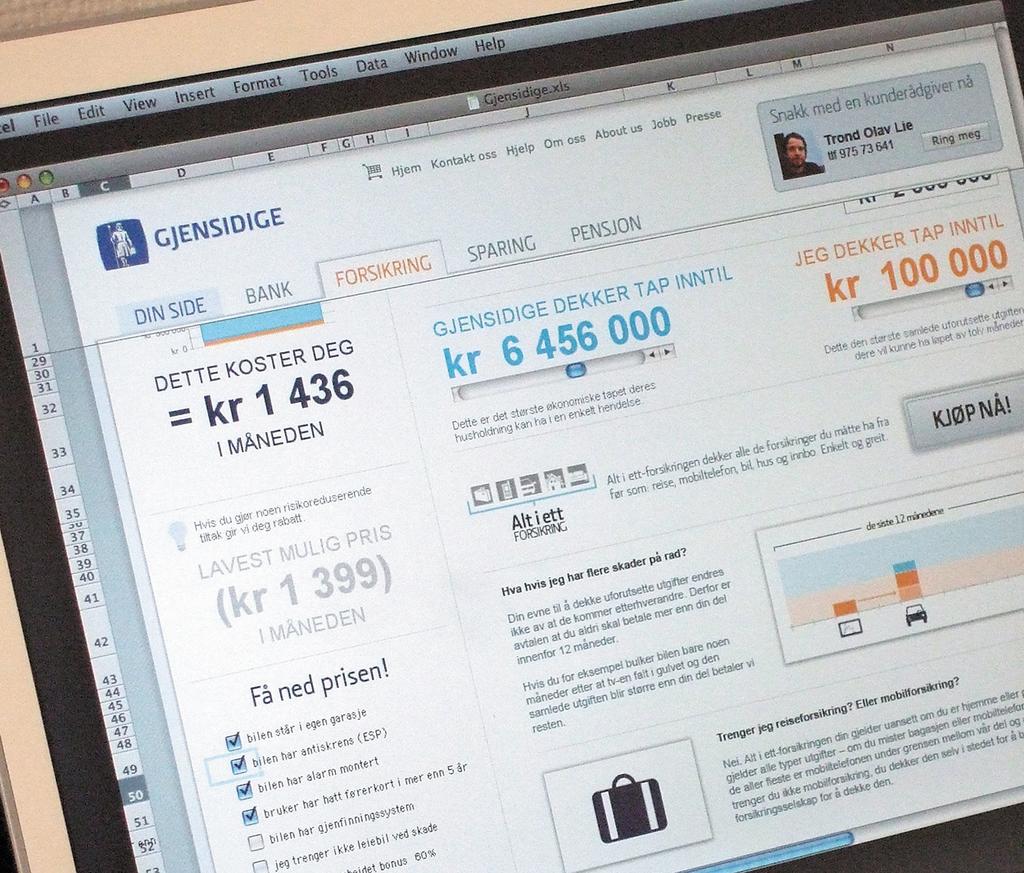What tab file is currently open?
Your answer should be very brief. Forsikring. What equals kr 1 436?
Provide a succinct answer. Dette koster deg. 